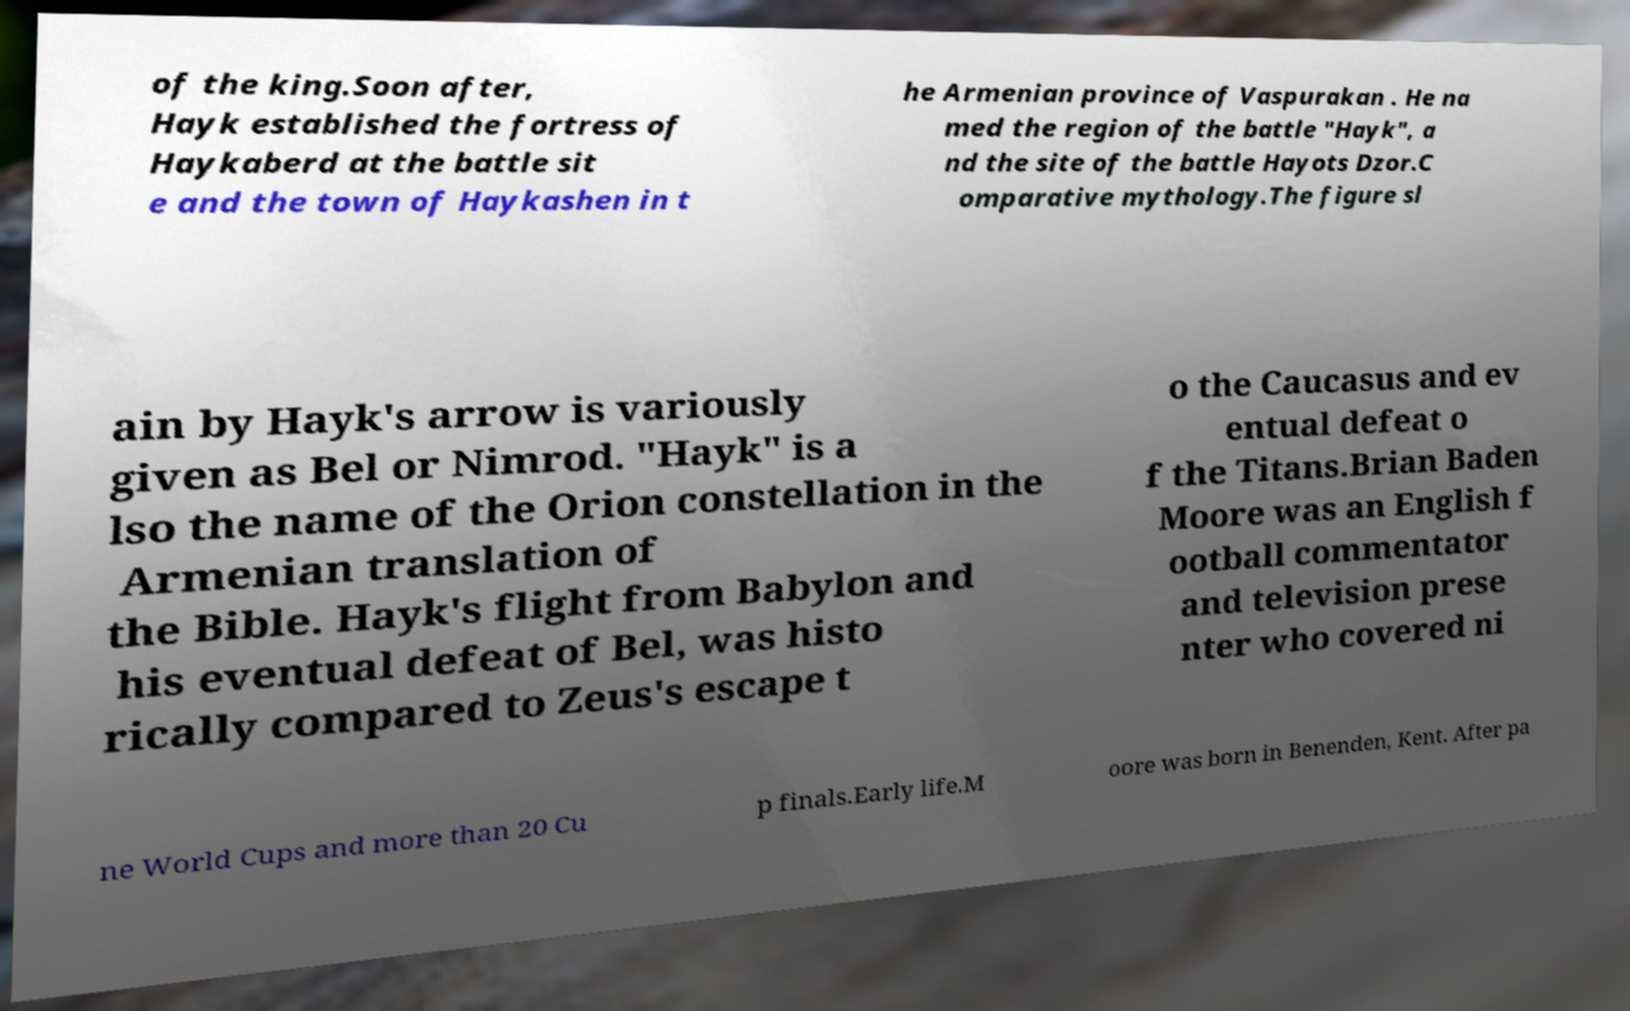I need the written content from this picture converted into text. Can you do that? of the king.Soon after, Hayk established the fortress of Haykaberd at the battle sit e and the town of Haykashen in t he Armenian province of Vaspurakan . He na med the region of the battle "Hayk", a nd the site of the battle Hayots Dzor.C omparative mythology.The figure sl ain by Hayk's arrow is variously given as Bel or Nimrod. "Hayk" is a lso the name of the Orion constellation in the Armenian translation of the Bible. Hayk's flight from Babylon and his eventual defeat of Bel, was histo rically compared to Zeus's escape t o the Caucasus and ev entual defeat o f the Titans.Brian Baden Moore was an English f ootball commentator and television prese nter who covered ni ne World Cups and more than 20 Cu p finals.Early life.M oore was born in Benenden, Kent. After pa 